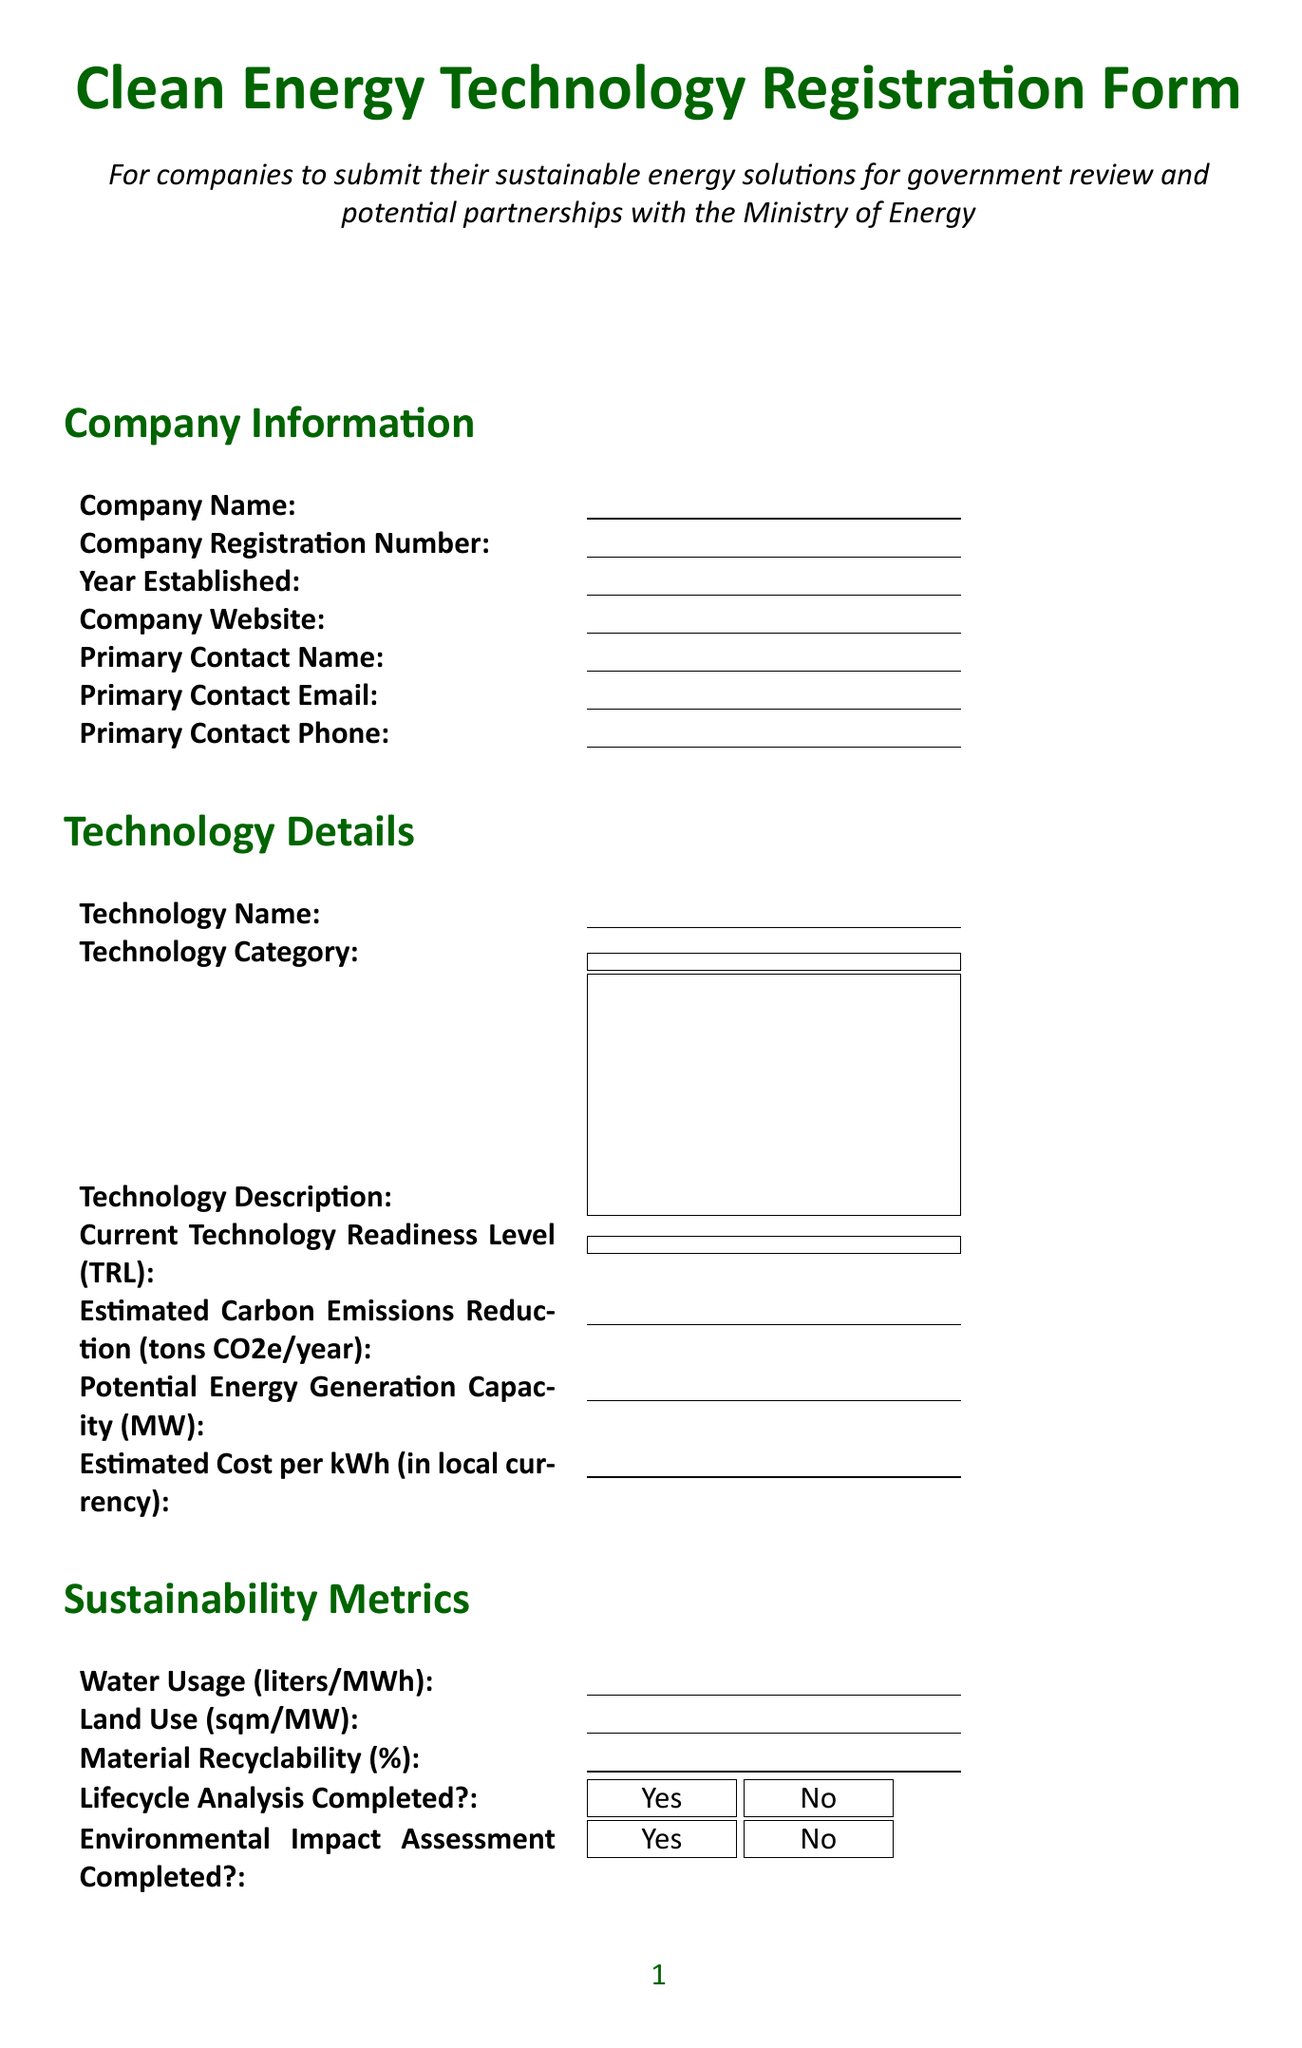what is the title of the form? The title of the form is provided at the beginning of the document.
Answer: Clean Energy Technology Registration Form how many years since the company was established? The field for Year Established allows for a number indicating the year the company was established.
Answer: Number what is the estimated carbon emissions reduction? The document explicitly requests the estimated carbon emissions reduction in tons CO2e per year.
Answer: Number what are the options for technology categories? The document lists various technology categories as part of the technology details section.
Answer: Solar Energy, Wind Energy, Hydroelectric Power, Geothermal Energy, Biomass Energy, Energy Storage, Smart Grid Solutions, Energy Efficiency Technologies, Other what type of government support is desired? The document lists multiple options for desired government support, which can be selected.
Answer: Research & Development Funding, Pilot Project Funding, Tax Incentives, Regulatory Support, Public-Private Partnership, Market Access Support, Other what level of technology readiness can be indicated? The document provides a dropdown of specified options for indicating the current technology readiness level (TRL).
Answer: TRL 1, TRL 2, TRL 3, TRL 4, TRL 5, TRL 6, TRL 7, TRL 8, TRL 9 is lifecycle analysis completed? The form includes a question to indicate whether a lifecycle analysis has been completed.
Answer: Yes or No what is required in the additional information section? The additional information section outlines various optional fields to provide further details about the technology.
Answer: Patents or Intellectual Property, Certifications or Standards Compliance, References or Case Studies, Additional Comments 